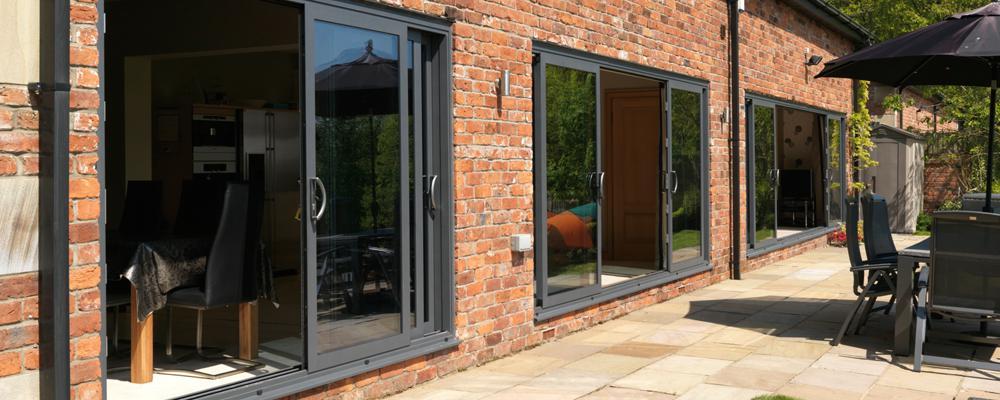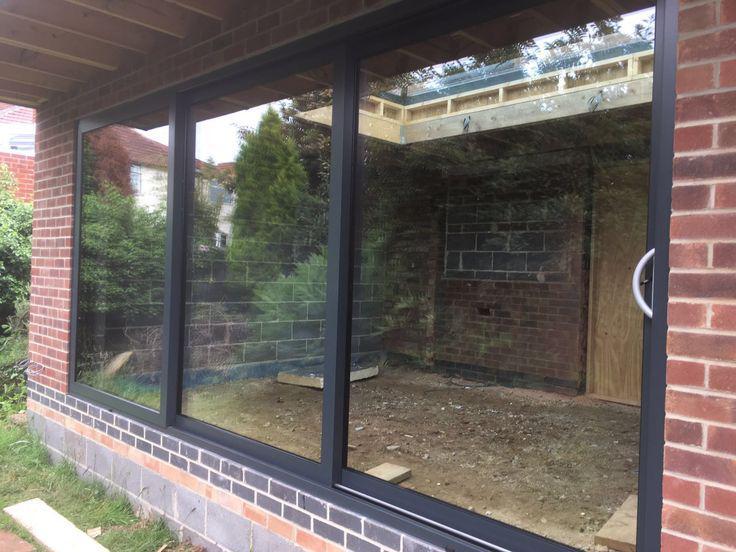The first image is the image on the left, the second image is the image on the right. Assess this claim about the two images: "The doors in one of the images opens to an area that has at least one chair.". Correct or not? Answer yes or no. Yes. The first image is the image on the left, the second image is the image on the right. Assess this claim about the two images: "An image shows a brick wall with one multi-door sliding glass element that is open in the center, revealing a room of furniture.". Correct or not? Answer yes or no. No. 